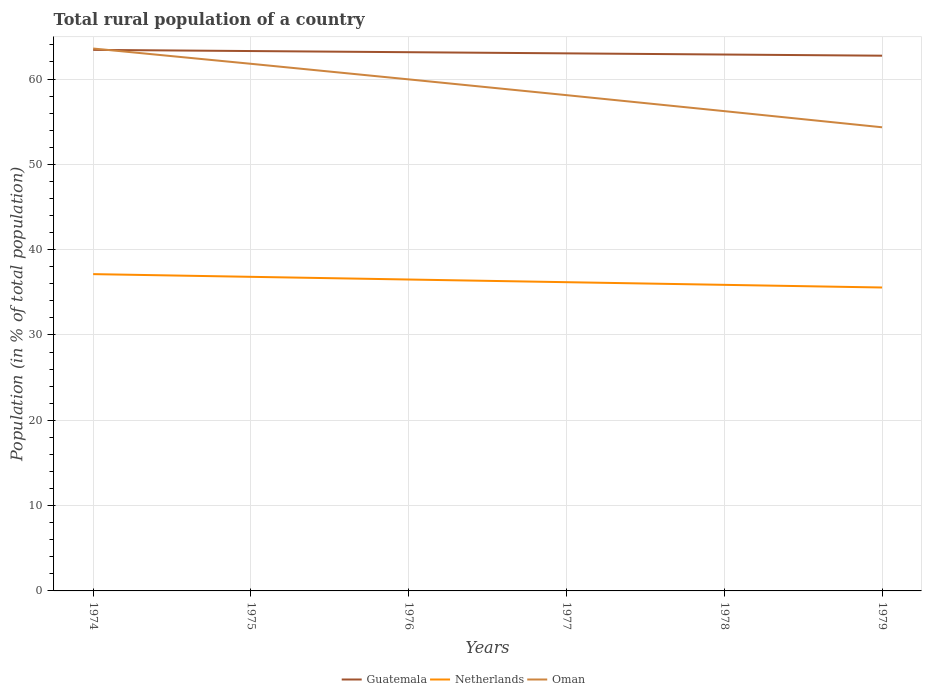Does the line corresponding to Guatemala intersect with the line corresponding to Oman?
Your answer should be compact. Yes. Is the number of lines equal to the number of legend labels?
Give a very brief answer. Yes. Across all years, what is the maximum rural population in Guatemala?
Provide a succinct answer. 62.74. In which year was the rural population in Oman maximum?
Keep it short and to the point. 1979. What is the total rural population in Oman in the graph?
Provide a short and direct response. 1.79. What is the difference between the highest and the second highest rural population in Guatemala?
Offer a very short reply. 0.68. What is the difference between the highest and the lowest rural population in Netherlands?
Offer a very short reply. 3. How many lines are there?
Your answer should be compact. 3. How many years are there in the graph?
Your answer should be very brief. 6. Are the values on the major ticks of Y-axis written in scientific E-notation?
Offer a terse response. No. Does the graph contain any zero values?
Offer a terse response. No. Does the graph contain grids?
Offer a terse response. Yes. Where does the legend appear in the graph?
Offer a terse response. Bottom center. How are the legend labels stacked?
Give a very brief answer. Horizontal. What is the title of the graph?
Provide a short and direct response. Total rural population of a country. What is the label or title of the X-axis?
Provide a short and direct response. Years. What is the label or title of the Y-axis?
Give a very brief answer. Population (in % of total population). What is the Population (in % of total population) of Guatemala in 1974?
Your response must be concise. 63.42. What is the Population (in % of total population) in Netherlands in 1974?
Your answer should be compact. 37.13. What is the Population (in % of total population) of Oman in 1974?
Offer a terse response. 63.58. What is the Population (in % of total population) in Guatemala in 1975?
Provide a succinct answer. 63.28. What is the Population (in % of total population) of Netherlands in 1975?
Your response must be concise. 36.82. What is the Population (in % of total population) in Oman in 1975?
Ensure brevity in your answer.  61.79. What is the Population (in % of total population) of Guatemala in 1976?
Provide a succinct answer. 63.15. What is the Population (in % of total population) in Netherlands in 1976?
Keep it short and to the point. 36.5. What is the Population (in % of total population) of Oman in 1976?
Your answer should be compact. 59.96. What is the Population (in % of total population) of Guatemala in 1977?
Your answer should be very brief. 63.01. What is the Population (in % of total population) of Netherlands in 1977?
Your answer should be compact. 36.19. What is the Population (in % of total population) of Oman in 1977?
Your answer should be very brief. 58.11. What is the Population (in % of total population) of Guatemala in 1978?
Provide a succinct answer. 62.87. What is the Population (in % of total population) of Netherlands in 1978?
Provide a succinct answer. 35.88. What is the Population (in % of total population) in Oman in 1978?
Your response must be concise. 56.24. What is the Population (in % of total population) of Guatemala in 1979?
Offer a terse response. 62.74. What is the Population (in % of total population) of Netherlands in 1979?
Your answer should be very brief. 35.56. What is the Population (in % of total population) of Oman in 1979?
Provide a short and direct response. 54.35. Across all years, what is the maximum Population (in % of total population) in Guatemala?
Give a very brief answer. 63.42. Across all years, what is the maximum Population (in % of total population) in Netherlands?
Provide a succinct answer. 37.13. Across all years, what is the maximum Population (in % of total population) of Oman?
Provide a short and direct response. 63.58. Across all years, what is the minimum Population (in % of total population) in Guatemala?
Offer a very short reply. 62.74. Across all years, what is the minimum Population (in % of total population) of Netherlands?
Offer a very short reply. 35.56. Across all years, what is the minimum Population (in % of total population) in Oman?
Make the answer very short. 54.35. What is the total Population (in % of total population) in Guatemala in the graph?
Your answer should be compact. 378.47. What is the total Population (in % of total population) in Netherlands in the graph?
Offer a terse response. 218.08. What is the total Population (in % of total population) of Oman in the graph?
Provide a short and direct response. 354.02. What is the difference between the Population (in % of total population) of Guatemala in 1974 and that in 1975?
Ensure brevity in your answer.  0.14. What is the difference between the Population (in % of total population) in Netherlands in 1974 and that in 1975?
Your answer should be very brief. 0.32. What is the difference between the Population (in % of total population) of Oman in 1974 and that in 1975?
Make the answer very short. 1.79. What is the difference between the Population (in % of total population) in Guatemala in 1974 and that in 1976?
Your response must be concise. 0.27. What is the difference between the Population (in % of total population) in Netherlands in 1974 and that in 1976?
Your answer should be very brief. 0.63. What is the difference between the Population (in % of total population) of Oman in 1974 and that in 1976?
Offer a very short reply. 3.62. What is the difference between the Population (in % of total population) in Guatemala in 1974 and that in 1977?
Make the answer very short. 0.41. What is the difference between the Population (in % of total population) in Netherlands in 1974 and that in 1977?
Your response must be concise. 0.94. What is the difference between the Population (in % of total population) of Oman in 1974 and that in 1977?
Your answer should be compact. 5.46. What is the difference between the Population (in % of total population) in Guatemala in 1974 and that in 1978?
Keep it short and to the point. 0.55. What is the difference between the Population (in % of total population) in Netherlands in 1974 and that in 1978?
Offer a very short reply. 1.26. What is the difference between the Population (in % of total population) of Oman in 1974 and that in 1978?
Provide a short and direct response. 7.34. What is the difference between the Population (in % of total population) of Guatemala in 1974 and that in 1979?
Your answer should be compact. 0.68. What is the difference between the Population (in % of total population) in Netherlands in 1974 and that in 1979?
Your answer should be compact. 1.57. What is the difference between the Population (in % of total population) of Oman in 1974 and that in 1979?
Your answer should be compact. 9.23. What is the difference between the Population (in % of total population) in Guatemala in 1975 and that in 1976?
Your response must be concise. 0.14. What is the difference between the Population (in % of total population) of Netherlands in 1975 and that in 1976?
Provide a succinct answer. 0.32. What is the difference between the Population (in % of total population) of Oman in 1975 and that in 1976?
Ensure brevity in your answer.  1.83. What is the difference between the Population (in % of total population) of Guatemala in 1975 and that in 1977?
Make the answer very short. 0.27. What is the difference between the Population (in % of total population) in Netherlands in 1975 and that in 1977?
Your answer should be compact. 0.63. What is the difference between the Population (in % of total population) in Oman in 1975 and that in 1977?
Provide a succinct answer. 3.67. What is the difference between the Population (in % of total population) of Guatemala in 1975 and that in 1978?
Your response must be concise. 0.41. What is the difference between the Population (in % of total population) of Oman in 1975 and that in 1978?
Your response must be concise. 5.55. What is the difference between the Population (in % of total population) in Guatemala in 1975 and that in 1979?
Make the answer very short. 0.55. What is the difference between the Population (in % of total population) of Netherlands in 1975 and that in 1979?
Give a very brief answer. 1.25. What is the difference between the Population (in % of total population) of Oman in 1975 and that in 1979?
Give a very brief answer. 7.44. What is the difference between the Population (in % of total population) in Guatemala in 1976 and that in 1977?
Offer a very short reply. 0.14. What is the difference between the Population (in % of total population) in Netherlands in 1976 and that in 1977?
Provide a short and direct response. 0.31. What is the difference between the Population (in % of total population) in Oman in 1976 and that in 1977?
Provide a succinct answer. 1.85. What is the difference between the Population (in % of total population) in Guatemala in 1976 and that in 1978?
Your response must be concise. 0.27. What is the difference between the Population (in % of total population) of Netherlands in 1976 and that in 1978?
Provide a succinct answer. 0.62. What is the difference between the Population (in % of total population) in Oman in 1976 and that in 1978?
Your answer should be very brief. 3.72. What is the difference between the Population (in % of total population) in Guatemala in 1976 and that in 1979?
Provide a short and direct response. 0.41. What is the difference between the Population (in % of total population) of Netherlands in 1976 and that in 1979?
Provide a short and direct response. 0.94. What is the difference between the Population (in % of total population) in Oman in 1976 and that in 1979?
Your answer should be very brief. 5.62. What is the difference between the Population (in % of total population) in Guatemala in 1977 and that in 1978?
Ensure brevity in your answer.  0.14. What is the difference between the Population (in % of total population) in Netherlands in 1977 and that in 1978?
Offer a very short reply. 0.31. What is the difference between the Population (in % of total population) of Oman in 1977 and that in 1978?
Make the answer very short. 1.87. What is the difference between the Population (in % of total population) in Guatemala in 1977 and that in 1979?
Your answer should be very brief. 0.27. What is the difference between the Population (in % of total population) in Netherlands in 1977 and that in 1979?
Provide a succinct answer. 0.62. What is the difference between the Population (in % of total population) in Oman in 1977 and that in 1979?
Your answer should be compact. 3.77. What is the difference between the Population (in % of total population) of Guatemala in 1978 and that in 1979?
Keep it short and to the point. 0.14. What is the difference between the Population (in % of total population) in Netherlands in 1978 and that in 1979?
Offer a very short reply. 0.31. What is the difference between the Population (in % of total population) in Oman in 1978 and that in 1979?
Provide a short and direct response. 1.89. What is the difference between the Population (in % of total population) of Guatemala in 1974 and the Population (in % of total population) of Netherlands in 1975?
Your response must be concise. 26.6. What is the difference between the Population (in % of total population) in Guatemala in 1974 and the Population (in % of total population) in Oman in 1975?
Offer a terse response. 1.63. What is the difference between the Population (in % of total population) in Netherlands in 1974 and the Population (in % of total population) in Oman in 1975?
Ensure brevity in your answer.  -24.65. What is the difference between the Population (in % of total population) in Guatemala in 1974 and the Population (in % of total population) in Netherlands in 1976?
Your answer should be very brief. 26.92. What is the difference between the Population (in % of total population) of Guatemala in 1974 and the Population (in % of total population) of Oman in 1976?
Make the answer very short. 3.46. What is the difference between the Population (in % of total population) of Netherlands in 1974 and the Population (in % of total population) of Oman in 1976?
Your answer should be very brief. -22.83. What is the difference between the Population (in % of total population) of Guatemala in 1974 and the Population (in % of total population) of Netherlands in 1977?
Offer a very short reply. 27.23. What is the difference between the Population (in % of total population) of Guatemala in 1974 and the Population (in % of total population) of Oman in 1977?
Provide a short and direct response. 5.31. What is the difference between the Population (in % of total population) in Netherlands in 1974 and the Population (in % of total population) in Oman in 1977?
Your answer should be compact. -20.98. What is the difference between the Population (in % of total population) in Guatemala in 1974 and the Population (in % of total population) in Netherlands in 1978?
Provide a succinct answer. 27.54. What is the difference between the Population (in % of total population) of Guatemala in 1974 and the Population (in % of total population) of Oman in 1978?
Offer a terse response. 7.18. What is the difference between the Population (in % of total population) of Netherlands in 1974 and the Population (in % of total population) of Oman in 1978?
Your response must be concise. -19.11. What is the difference between the Population (in % of total population) in Guatemala in 1974 and the Population (in % of total population) in Netherlands in 1979?
Offer a terse response. 27.85. What is the difference between the Population (in % of total population) in Guatemala in 1974 and the Population (in % of total population) in Oman in 1979?
Your answer should be compact. 9.07. What is the difference between the Population (in % of total population) of Netherlands in 1974 and the Population (in % of total population) of Oman in 1979?
Ensure brevity in your answer.  -17.21. What is the difference between the Population (in % of total population) of Guatemala in 1975 and the Population (in % of total population) of Netherlands in 1976?
Provide a succinct answer. 26.78. What is the difference between the Population (in % of total population) in Guatemala in 1975 and the Population (in % of total population) in Oman in 1976?
Your response must be concise. 3.32. What is the difference between the Population (in % of total population) in Netherlands in 1975 and the Population (in % of total population) in Oman in 1976?
Provide a short and direct response. -23.14. What is the difference between the Population (in % of total population) of Guatemala in 1975 and the Population (in % of total population) of Netherlands in 1977?
Keep it short and to the point. 27.09. What is the difference between the Population (in % of total population) in Guatemala in 1975 and the Population (in % of total population) in Oman in 1977?
Your answer should be very brief. 5.17. What is the difference between the Population (in % of total population) in Netherlands in 1975 and the Population (in % of total population) in Oman in 1977?
Offer a terse response. -21.3. What is the difference between the Population (in % of total population) in Guatemala in 1975 and the Population (in % of total population) in Netherlands in 1978?
Make the answer very short. 27.41. What is the difference between the Population (in % of total population) of Guatemala in 1975 and the Population (in % of total population) of Oman in 1978?
Keep it short and to the point. 7.04. What is the difference between the Population (in % of total population) in Netherlands in 1975 and the Population (in % of total population) in Oman in 1978?
Your response must be concise. -19.42. What is the difference between the Population (in % of total population) of Guatemala in 1975 and the Population (in % of total population) of Netherlands in 1979?
Provide a succinct answer. 27.72. What is the difference between the Population (in % of total population) of Guatemala in 1975 and the Population (in % of total population) of Oman in 1979?
Offer a very short reply. 8.94. What is the difference between the Population (in % of total population) of Netherlands in 1975 and the Population (in % of total population) of Oman in 1979?
Make the answer very short. -17.53. What is the difference between the Population (in % of total population) of Guatemala in 1976 and the Population (in % of total population) of Netherlands in 1977?
Offer a very short reply. 26.96. What is the difference between the Population (in % of total population) in Guatemala in 1976 and the Population (in % of total population) in Oman in 1977?
Your response must be concise. 5.03. What is the difference between the Population (in % of total population) in Netherlands in 1976 and the Population (in % of total population) in Oman in 1977?
Offer a terse response. -21.61. What is the difference between the Population (in % of total population) in Guatemala in 1976 and the Population (in % of total population) in Netherlands in 1978?
Your response must be concise. 27.27. What is the difference between the Population (in % of total population) of Guatemala in 1976 and the Population (in % of total population) of Oman in 1978?
Provide a short and direct response. 6.91. What is the difference between the Population (in % of total population) of Netherlands in 1976 and the Population (in % of total population) of Oman in 1978?
Your response must be concise. -19.74. What is the difference between the Population (in % of total population) of Guatemala in 1976 and the Population (in % of total population) of Netherlands in 1979?
Provide a short and direct response. 27.58. What is the difference between the Population (in % of total population) in Guatemala in 1976 and the Population (in % of total population) in Oman in 1979?
Provide a succinct answer. 8.8. What is the difference between the Population (in % of total population) in Netherlands in 1976 and the Population (in % of total population) in Oman in 1979?
Your response must be concise. -17.84. What is the difference between the Population (in % of total population) in Guatemala in 1977 and the Population (in % of total population) in Netherlands in 1978?
Make the answer very short. 27.13. What is the difference between the Population (in % of total population) of Guatemala in 1977 and the Population (in % of total population) of Oman in 1978?
Provide a short and direct response. 6.77. What is the difference between the Population (in % of total population) in Netherlands in 1977 and the Population (in % of total population) in Oman in 1978?
Your answer should be compact. -20.05. What is the difference between the Population (in % of total population) in Guatemala in 1977 and the Population (in % of total population) in Netherlands in 1979?
Provide a succinct answer. 27.45. What is the difference between the Population (in % of total population) of Guatemala in 1977 and the Population (in % of total population) of Oman in 1979?
Offer a very short reply. 8.66. What is the difference between the Population (in % of total population) of Netherlands in 1977 and the Population (in % of total population) of Oman in 1979?
Your response must be concise. -18.16. What is the difference between the Population (in % of total population) in Guatemala in 1978 and the Population (in % of total population) in Netherlands in 1979?
Your response must be concise. 27.31. What is the difference between the Population (in % of total population) in Guatemala in 1978 and the Population (in % of total population) in Oman in 1979?
Provide a succinct answer. 8.53. What is the difference between the Population (in % of total population) of Netherlands in 1978 and the Population (in % of total population) of Oman in 1979?
Make the answer very short. -18.47. What is the average Population (in % of total population) in Guatemala per year?
Make the answer very short. 63.08. What is the average Population (in % of total population) of Netherlands per year?
Keep it short and to the point. 36.35. What is the average Population (in % of total population) in Oman per year?
Make the answer very short. 59. In the year 1974, what is the difference between the Population (in % of total population) of Guatemala and Population (in % of total population) of Netherlands?
Offer a terse response. 26.29. In the year 1974, what is the difference between the Population (in % of total population) in Guatemala and Population (in % of total population) in Oman?
Keep it short and to the point. -0.16. In the year 1974, what is the difference between the Population (in % of total population) in Netherlands and Population (in % of total population) in Oman?
Ensure brevity in your answer.  -26.44. In the year 1975, what is the difference between the Population (in % of total population) of Guatemala and Population (in % of total population) of Netherlands?
Offer a very short reply. 26.46. In the year 1975, what is the difference between the Population (in % of total population) of Guatemala and Population (in % of total population) of Oman?
Your answer should be very brief. 1.5. In the year 1975, what is the difference between the Population (in % of total population) in Netherlands and Population (in % of total population) in Oman?
Your answer should be very brief. -24.97. In the year 1976, what is the difference between the Population (in % of total population) in Guatemala and Population (in % of total population) in Netherlands?
Keep it short and to the point. 26.64. In the year 1976, what is the difference between the Population (in % of total population) in Guatemala and Population (in % of total population) in Oman?
Provide a short and direct response. 3.19. In the year 1976, what is the difference between the Population (in % of total population) in Netherlands and Population (in % of total population) in Oman?
Provide a short and direct response. -23.46. In the year 1977, what is the difference between the Population (in % of total population) of Guatemala and Population (in % of total population) of Netherlands?
Provide a short and direct response. 26.82. In the year 1977, what is the difference between the Population (in % of total population) of Guatemala and Population (in % of total population) of Oman?
Your answer should be compact. 4.9. In the year 1977, what is the difference between the Population (in % of total population) in Netherlands and Population (in % of total population) in Oman?
Make the answer very short. -21.92. In the year 1978, what is the difference between the Population (in % of total population) in Guatemala and Population (in % of total population) in Netherlands?
Give a very brief answer. 27. In the year 1978, what is the difference between the Population (in % of total population) in Guatemala and Population (in % of total population) in Oman?
Provide a short and direct response. 6.63. In the year 1978, what is the difference between the Population (in % of total population) in Netherlands and Population (in % of total population) in Oman?
Ensure brevity in your answer.  -20.36. In the year 1979, what is the difference between the Population (in % of total population) in Guatemala and Population (in % of total population) in Netherlands?
Your answer should be very brief. 27.17. In the year 1979, what is the difference between the Population (in % of total population) of Guatemala and Population (in % of total population) of Oman?
Make the answer very short. 8.39. In the year 1979, what is the difference between the Population (in % of total population) in Netherlands and Population (in % of total population) in Oman?
Provide a short and direct response. -18.78. What is the ratio of the Population (in % of total population) of Guatemala in 1974 to that in 1975?
Your answer should be very brief. 1. What is the ratio of the Population (in % of total population) of Netherlands in 1974 to that in 1975?
Offer a terse response. 1.01. What is the ratio of the Population (in % of total population) of Netherlands in 1974 to that in 1976?
Make the answer very short. 1.02. What is the ratio of the Population (in % of total population) of Oman in 1974 to that in 1976?
Provide a succinct answer. 1.06. What is the ratio of the Population (in % of total population) of Netherlands in 1974 to that in 1977?
Your answer should be compact. 1.03. What is the ratio of the Population (in % of total population) in Oman in 1974 to that in 1977?
Provide a succinct answer. 1.09. What is the ratio of the Population (in % of total population) in Guatemala in 1974 to that in 1978?
Give a very brief answer. 1.01. What is the ratio of the Population (in % of total population) of Netherlands in 1974 to that in 1978?
Your answer should be compact. 1.03. What is the ratio of the Population (in % of total population) of Oman in 1974 to that in 1978?
Your answer should be compact. 1.13. What is the ratio of the Population (in % of total population) in Guatemala in 1974 to that in 1979?
Keep it short and to the point. 1.01. What is the ratio of the Population (in % of total population) in Netherlands in 1974 to that in 1979?
Make the answer very short. 1.04. What is the ratio of the Population (in % of total population) of Oman in 1974 to that in 1979?
Keep it short and to the point. 1.17. What is the ratio of the Population (in % of total population) in Netherlands in 1975 to that in 1976?
Offer a terse response. 1.01. What is the ratio of the Population (in % of total population) of Oman in 1975 to that in 1976?
Provide a succinct answer. 1.03. What is the ratio of the Population (in % of total population) of Guatemala in 1975 to that in 1977?
Provide a succinct answer. 1. What is the ratio of the Population (in % of total population) in Netherlands in 1975 to that in 1977?
Your response must be concise. 1.02. What is the ratio of the Population (in % of total population) in Oman in 1975 to that in 1977?
Provide a short and direct response. 1.06. What is the ratio of the Population (in % of total population) of Netherlands in 1975 to that in 1978?
Give a very brief answer. 1.03. What is the ratio of the Population (in % of total population) in Oman in 1975 to that in 1978?
Give a very brief answer. 1.1. What is the ratio of the Population (in % of total population) of Guatemala in 1975 to that in 1979?
Offer a very short reply. 1.01. What is the ratio of the Population (in % of total population) in Netherlands in 1975 to that in 1979?
Your response must be concise. 1.04. What is the ratio of the Population (in % of total population) of Oman in 1975 to that in 1979?
Your answer should be very brief. 1.14. What is the ratio of the Population (in % of total population) of Guatemala in 1976 to that in 1977?
Ensure brevity in your answer.  1. What is the ratio of the Population (in % of total population) of Netherlands in 1976 to that in 1977?
Provide a succinct answer. 1.01. What is the ratio of the Population (in % of total population) of Oman in 1976 to that in 1977?
Your answer should be very brief. 1.03. What is the ratio of the Population (in % of total population) of Guatemala in 1976 to that in 1978?
Your answer should be very brief. 1. What is the ratio of the Population (in % of total population) in Netherlands in 1976 to that in 1978?
Your answer should be very brief. 1.02. What is the ratio of the Population (in % of total population) in Oman in 1976 to that in 1978?
Provide a short and direct response. 1.07. What is the ratio of the Population (in % of total population) in Netherlands in 1976 to that in 1979?
Ensure brevity in your answer.  1.03. What is the ratio of the Population (in % of total population) of Oman in 1976 to that in 1979?
Make the answer very short. 1.1. What is the ratio of the Population (in % of total population) in Netherlands in 1977 to that in 1978?
Offer a terse response. 1.01. What is the ratio of the Population (in % of total population) of Guatemala in 1977 to that in 1979?
Ensure brevity in your answer.  1. What is the ratio of the Population (in % of total population) of Netherlands in 1977 to that in 1979?
Offer a very short reply. 1.02. What is the ratio of the Population (in % of total population) in Oman in 1977 to that in 1979?
Your answer should be very brief. 1.07. What is the ratio of the Population (in % of total population) in Guatemala in 1978 to that in 1979?
Provide a short and direct response. 1. What is the ratio of the Population (in % of total population) of Netherlands in 1978 to that in 1979?
Keep it short and to the point. 1.01. What is the ratio of the Population (in % of total population) of Oman in 1978 to that in 1979?
Provide a short and direct response. 1.03. What is the difference between the highest and the second highest Population (in % of total population) of Guatemala?
Your answer should be compact. 0.14. What is the difference between the highest and the second highest Population (in % of total population) of Netherlands?
Offer a terse response. 0.32. What is the difference between the highest and the second highest Population (in % of total population) of Oman?
Keep it short and to the point. 1.79. What is the difference between the highest and the lowest Population (in % of total population) of Guatemala?
Your answer should be very brief. 0.68. What is the difference between the highest and the lowest Population (in % of total population) of Netherlands?
Your answer should be very brief. 1.57. What is the difference between the highest and the lowest Population (in % of total population) of Oman?
Give a very brief answer. 9.23. 